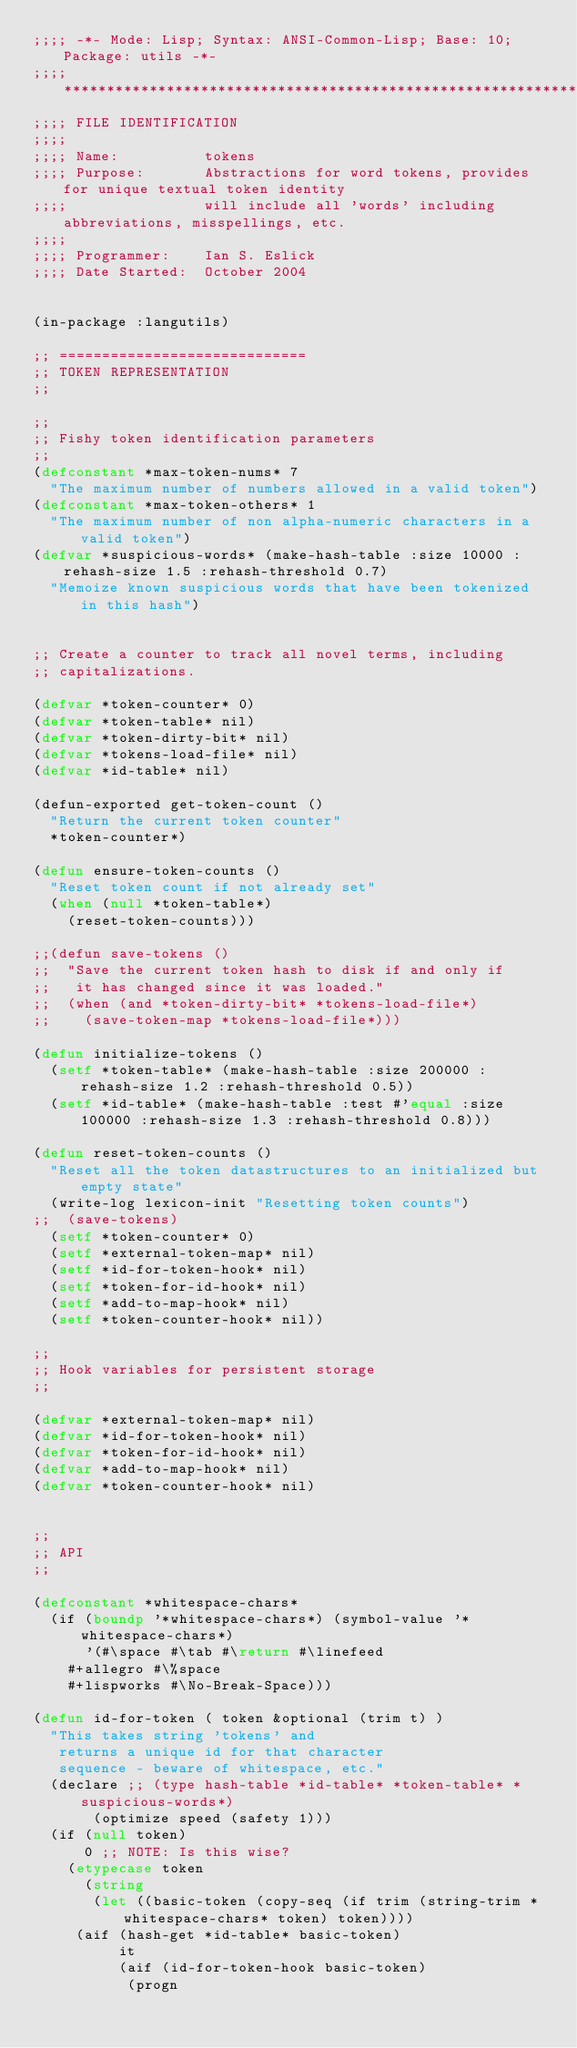<code> <loc_0><loc_0><loc_500><loc_500><_Lisp_>;;;; -*- Mode: Lisp; Syntax: ANSI-Common-Lisp; Base: 10; Package: utils -*-
;;;; *************************************************************************
;;;; FILE IDENTIFICATION
;;;;
;;;; Name:          tokens
;;;; Purpose:       Abstractions for word tokens, provides for unique textual token identity
;;;;                will include all 'words' including abbreviations, misspellings, etc.
;;;;
;;;; Programmer:    Ian S. Eslick
;;;; Date Started:  October 2004


(in-package :langutils)

;; =============================
;; TOKEN REPRESENTATION
;;

;; 
;; Fishy token identification parameters
;;
(defconstant *max-token-nums* 7
  "The maximum number of numbers allowed in a valid token")
(defconstant *max-token-others* 1
  "The maximum number of non alpha-numeric characters in a valid token")
(defvar *suspicious-words* (make-hash-table :size 10000 :rehash-size 1.5 :rehash-threshold 0.7)
  "Memoize known suspicious words that have been tokenized in this hash")


;; Create a counter to track all novel terms, including
;; capitalizations.

(defvar *token-counter* 0)
(defvar *token-table* nil)
(defvar *token-dirty-bit* nil)
(defvar *tokens-load-file* nil)
(defvar *id-table* nil)

(defun-exported get-token-count ()
  "Return the current token counter"
  *token-counter*)

(defun ensure-token-counts ()
  "Reset token count if not already set"
  (when (null *token-table*)
    (reset-token-counts)))

;;(defun save-tokens ()
;;  "Save the current token hash to disk if and only if
;;   it has changed since it was loaded."
;;  (when (and *token-dirty-bit* *tokens-load-file*)
;;    (save-token-map *tokens-load-file*)))

(defun initialize-tokens ()
  (setf *token-table* (make-hash-table :size 200000 :rehash-size 1.2 :rehash-threshold 0.5))
  (setf *id-table* (make-hash-table :test #'equal :size 100000 :rehash-size 1.3 :rehash-threshold 0.8)))

(defun reset-token-counts ()
  "Reset all the token datastructures to an initialized but empty state"
  (write-log lexicon-init "Resetting token counts")
;;  (save-tokens)
  (setf *token-counter* 0)
  (setf *external-token-map* nil)
  (setf *id-for-token-hook* nil)
  (setf *token-for-id-hook* nil)
  (setf *add-to-map-hook* nil)
  (setf *token-counter-hook* nil))

;;
;; Hook variables for persistent storage
;;

(defvar *external-token-map* nil)
(defvar *id-for-token-hook* nil)
(defvar *token-for-id-hook* nil)
(defvar *add-to-map-hook* nil)
(defvar *token-counter-hook* nil)


;;
;; API
;;

(defconstant *whitespace-chars* 
  (if (boundp '*whitespace-chars*) (symbol-value '*whitespace-chars*) 
      '(#\space #\tab #\return #\linefeed
	#+allegro #\%space
	#+lispworks #\No-Break-Space)))

(defun id-for-token ( token &optional (trim t) )
  "This takes string 'tokens' and 
   returns a unique id for that character
   sequence - beware of whitespace, etc."
  (declare ;; (type hash-table *id-table* *token-table* *suspicious-words*)
	   (optimize speed (safety 1)))
  (if (null token) 
      0 ;; NOTE: Is this wise?
    (etypecase token
      (string 
       (let ((basic-token (copy-seq (if trim (string-trim *whitespace-chars* token) token))))
	 (aif (hash-get *id-table* basic-token)
	      it
	      (aif (id-for-token-hook basic-token)
		   (progn</code> 